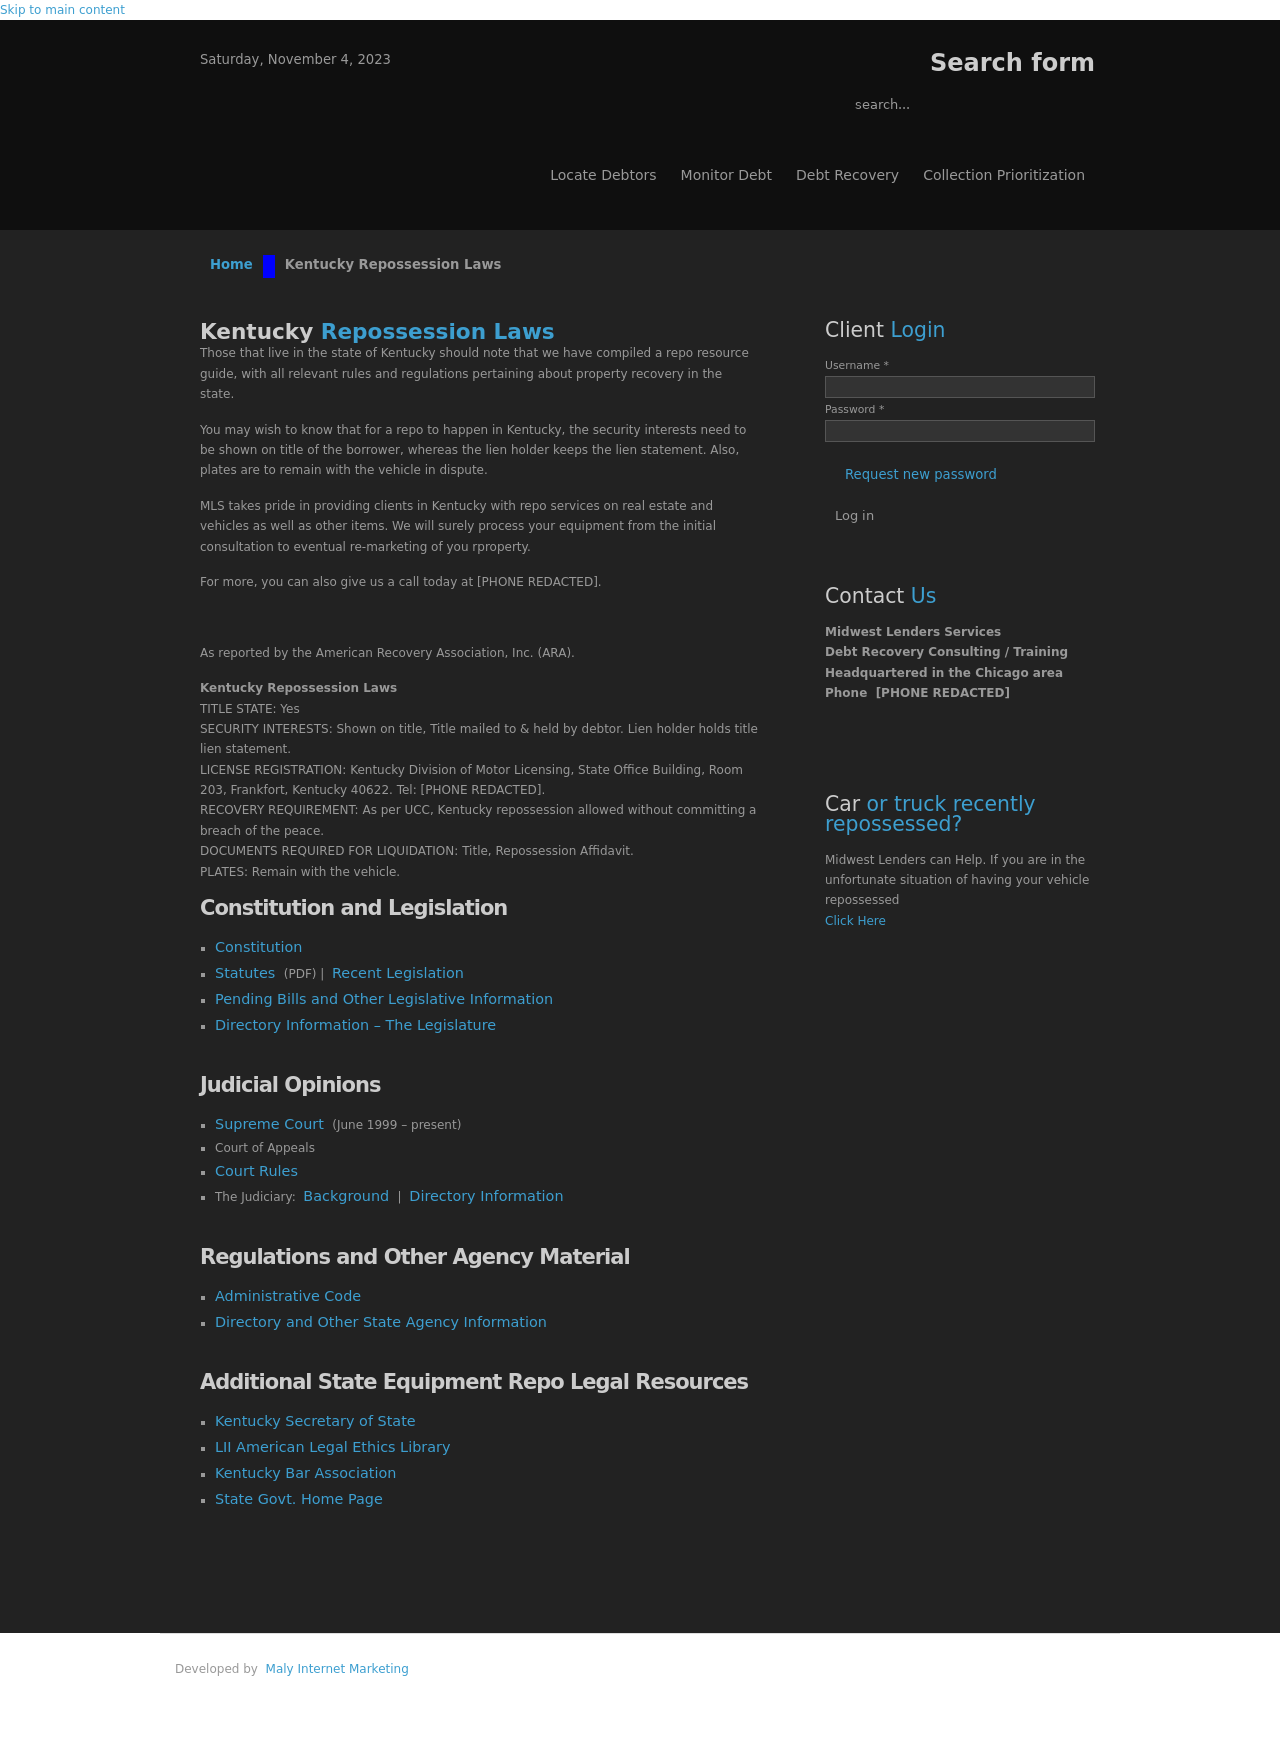What compliance considerations should be kept in mind when setting up a website dealing with debt recovery and repossession laws? When dealing with sensitive areas like debt recovery and repossession laws, ensuring compliance with legal regulations on data protection, such as GDPR or local laws like the California Consumer Privacy Act, is crucial. The website should have clear privacy policies, secure data handling practices, and regular audits to check compliance. Information provided must be accurate and up-to-date, reflecting current legal standards. 